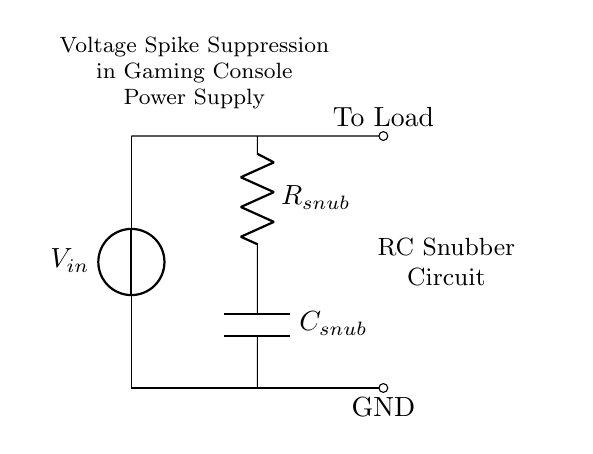What is the purpose of the RC snubber circuit? The purpose of the RC snubber circuit is to suppress voltage spikes in the power supply of gaming consoles, which can protect sensitive components from damage due to transient voltages.
Answer: Suppress voltage spikes What is the resistance value in the snubber circuit? The resistance value, labeled as R snub, indicates the resistance of the resistor in the snubber circuit, which is designed to dissipate energy during voltage spikes.
Answer: R snub What component is connected in parallel with the resistor? The capacitor, labeled as C snub, is connected in parallel with the resistor and works together with it to filter out high frequencies and reduce voltage spikes.
Answer: C snub What is connected to the output of the RC snubber circuit? The circuit diagram shows that the output of the RC snubber circuit is connected to the load, which represents the electronic components of the gaming console that requires stable voltage.
Answer: To Load How does the snubber circuit affect the voltage to the load? The snubber circuit acts to limit quick changes in voltage, reducing the peak voltages that reach the load during transient events, thus stabilizing the voltage supplied to the components.
Answer: Reduces peak voltages What happens if the resistance value is too high in the snubber circuit? If the resistance value is too high, the circuit may become ineffective at suppressing voltage spikes, as it would limit the current flowing through the capacitor too much, preventing it from charging and discharging effectively.
Answer: Ineffective suppression What is the voltage source value in the circuit? The voltage source, labeled as V in, represents the input voltage from the power supply that feeds into the snubber circuit before reaching the load.
Answer: V in 